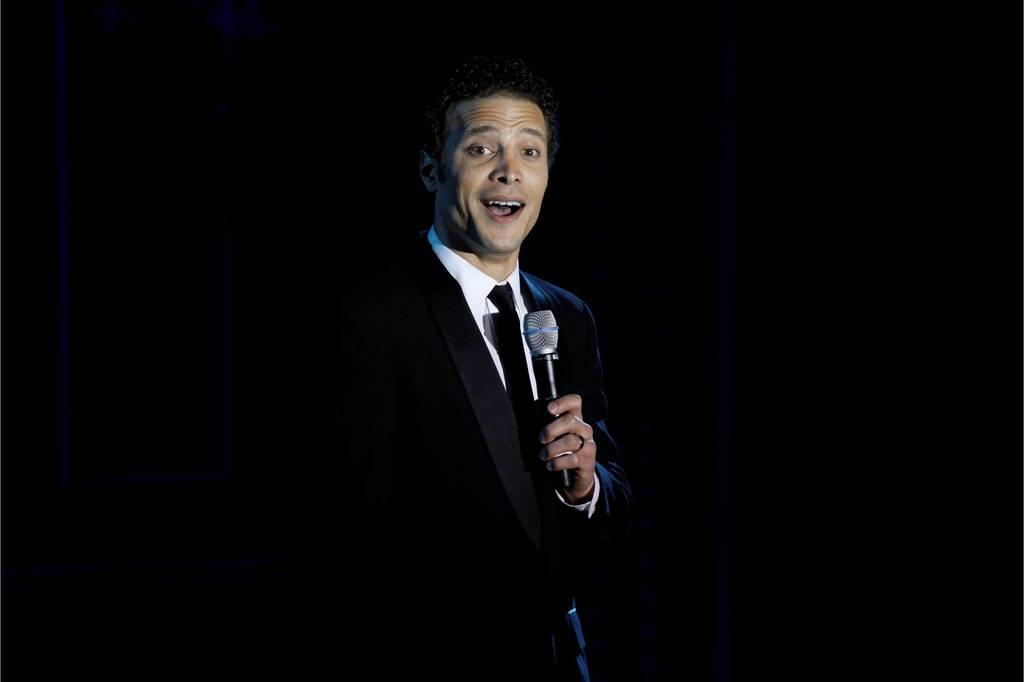Who is the main subject in the image? There is a man in the image. What is the man wearing? The man is wearing a black blazer. What is the man holding in the image? The man is holding a microphone. What is the man doing in the image? The man is talking. What is the color of the background in the image? The background of the image is black. How many examples of steel can be seen in the image? There is no steel present in the image. What is the man doing with his feet in the image? The image does not show the man's feet, so it cannot be determined what he is doing with them. 